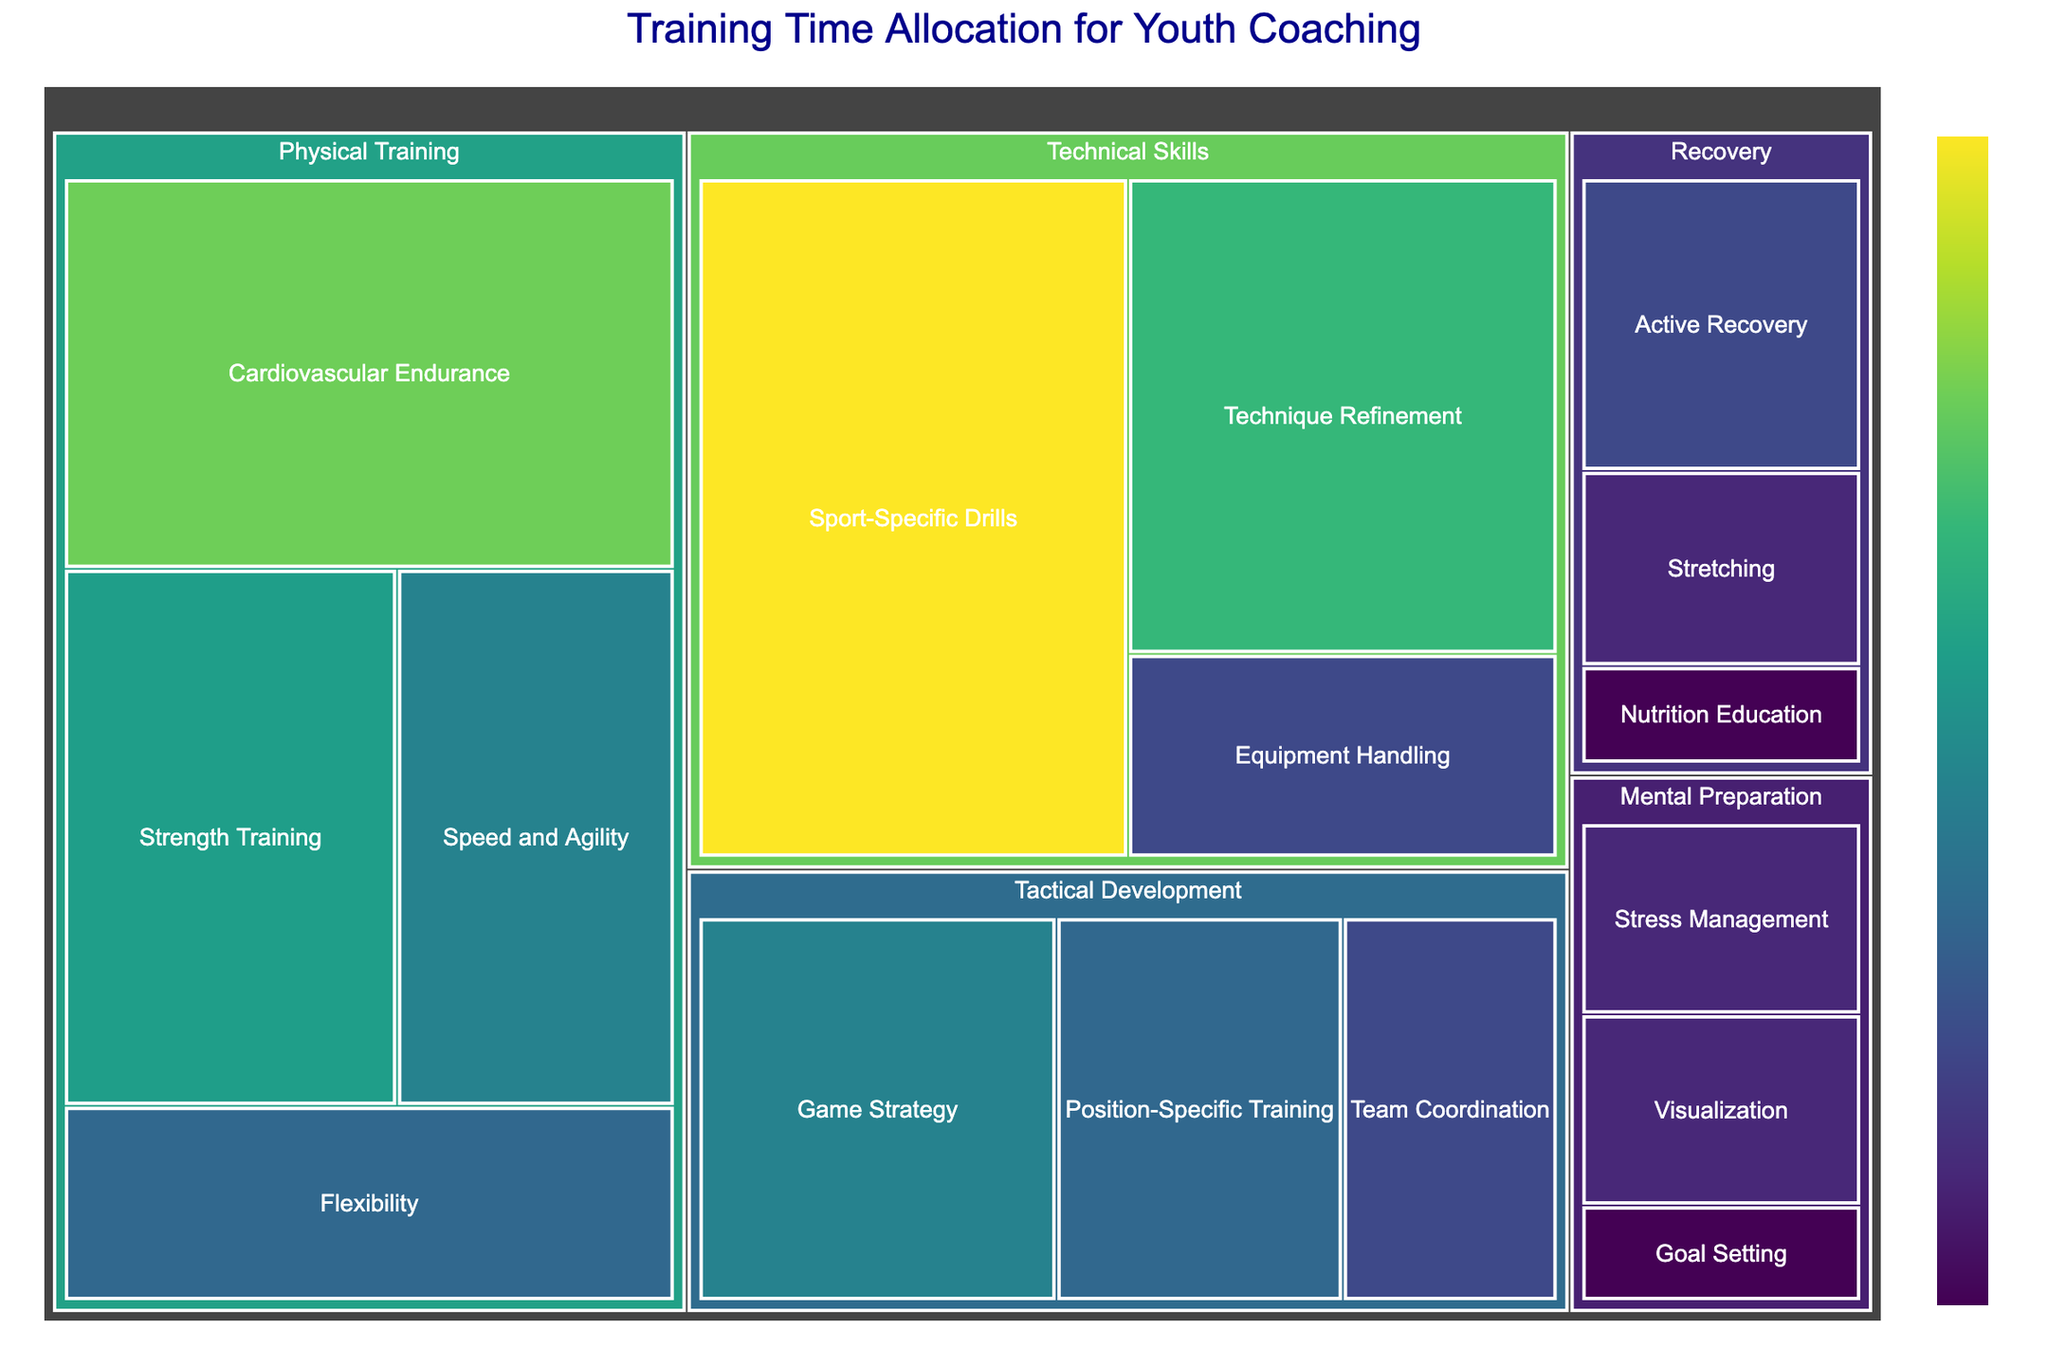What is the total training time allocated for Physical Training? To find the total training time for Physical Training, sum the hours for all its subcategories: Cardiovascular Endurance (8), Strength Training (6), Flexibility (4), and Speed and Agility (5). Total = 8 + 6 + 4 + 5 = 23.
Answer: 23 Which subcategory under Technical Skills has the maximum hours allocated? Within Technical Skills, compare the hours of Sport-Specific Drills (10), Technique Refinement (7), and Equipment Handling (3). Sport-Specific Drills has the highest with 10 hours.
Answer: Sport-Specific Drills How much more time is allocated to Game Strategy compared to Stress Management? Identify the hours for Game Strategy (5) and Stress Management (2). Calculate the difference: 5 - 2 = 3.
Answer: 3 What is the overall training time for all categories combined? Sum the hours from all subcategories: 8 + 6 + 4 + 5 + 10 + 7 + 3 + 5 + 4 + 3 + 2 + 1 + 2 + 3 + 2 + 1 = 66.
Answer: 66 Which category has the lowest total training hours, and how many hours are allocated to it? Examine the total hours for each category: Physical Training (23), Technical Skills (20), Tactical Development (12), Mental Preparation (5), Recovery (6). Mental Preparation has the lowest with 5 hours.
Answer: Mental Preparation, 5 Compare the total hours allocated to Tactical Development with Technical Skills. Which category has more hours? Sum the hours for Tactical Development (5 + 4 + 3 = 12) and Technical Skills (10 + 7 + 3 = 20). Technical Skills has more hours (20).
Answer: Technical Skills How is the time for Speed and Agility distributed in comparison to Flexibility? Speed and Agility has 5 hours, and Flexibility has 4 hours in Physical Training. Speed and Agility has 1 more hour than Flexibility.
Answer: Speed and Agility (5) > Flexibility (4) Calculate the average training time allocated per subcategory in Recovery. Recovery has three subcategories: Active Recovery (3), Stretching (2), Nutrition Education (1). Average = (3 + 2 + 1) / 3 = 6 / 3 = 2.
Answer: 2 